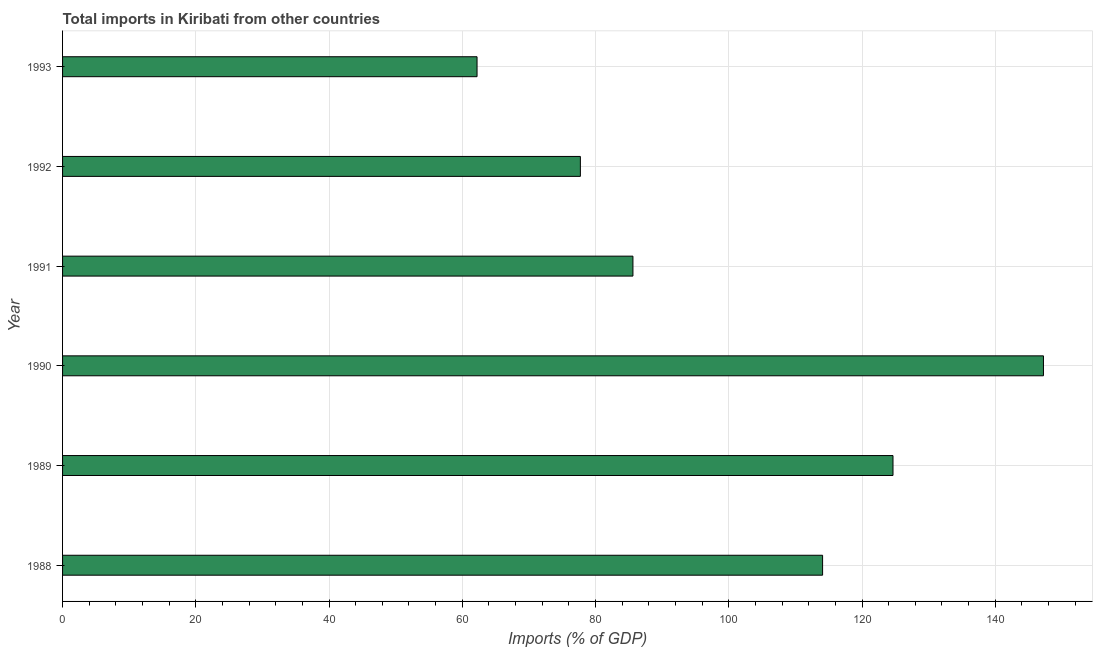Does the graph contain grids?
Your response must be concise. Yes. What is the title of the graph?
Your answer should be very brief. Total imports in Kiribati from other countries. What is the label or title of the X-axis?
Give a very brief answer. Imports (% of GDP). What is the label or title of the Y-axis?
Your answer should be compact. Year. What is the total imports in 1988?
Offer a very short reply. 114.08. Across all years, what is the maximum total imports?
Your response must be concise. 147.24. Across all years, what is the minimum total imports?
Provide a succinct answer. 62.22. In which year was the total imports minimum?
Provide a succinct answer. 1993. What is the sum of the total imports?
Your answer should be compact. 611.54. What is the difference between the total imports in 1989 and 1990?
Your answer should be very brief. -22.58. What is the average total imports per year?
Offer a very short reply. 101.92. What is the median total imports?
Offer a terse response. 99.85. In how many years, is the total imports greater than 64 %?
Give a very brief answer. 5. Do a majority of the years between 1991 and 1989 (inclusive) have total imports greater than 4 %?
Make the answer very short. Yes. What is the ratio of the total imports in 1989 to that in 1993?
Offer a terse response. 2. Is the difference between the total imports in 1992 and 1993 greater than the difference between any two years?
Keep it short and to the point. No. What is the difference between the highest and the second highest total imports?
Your answer should be very brief. 22.58. What is the difference between the highest and the lowest total imports?
Your answer should be very brief. 85.02. In how many years, is the total imports greater than the average total imports taken over all years?
Offer a very short reply. 3. Are the values on the major ticks of X-axis written in scientific E-notation?
Offer a terse response. No. What is the Imports (% of GDP) of 1988?
Provide a short and direct response. 114.08. What is the Imports (% of GDP) in 1989?
Give a very brief answer. 124.65. What is the Imports (% of GDP) in 1990?
Give a very brief answer. 147.24. What is the Imports (% of GDP) of 1991?
Your response must be concise. 85.62. What is the Imports (% of GDP) of 1992?
Provide a short and direct response. 77.73. What is the Imports (% of GDP) of 1993?
Your answer should be very brief. 62.22. What is the difference between the Imports (% of GDP) in 1988 and 1989?
Give a very brief answer. -10.57. What is the difference between the Imports (% of GDP) in 1988 and 1990?
Keep it short and to the point. -33.15. What is the difference between the Imports (% of GDP) in 1988 and 1991?
Ensure brevity in your answer.  28.47. What is the difference between the Imports (% of GDP) in 1988 and 1992?
Provide a succinct answer. 36.36. What is the difference between the Imports (% of GDP) in 1988 and 1993?
Give a very brief answer. 51.87. What is the difference between the Imports (% of GDP) in 1989 and 1990?
Your response must be concise. -22.58. What is the difference between the Imports (% of GDP) in 1989 and 1991?
Make the answer very short. 39.04. What is the difference between the Imports (% of GDP) in 1989 and 1992?
Ensure brevity in your answer.  46.93. What is the difference between the Imports (% of GDP) in 1989 and 1993?
Ensure brevity in your answer.  62.44. What is the difference between the Imports (% of GDP) in 1990 and 1991?
Keep it short and to the point. 61.62. What is the difference between the Imports (% of GDP) in 1990 and 1992?
Your response must be concise. 69.51. What is the difference between the Imports (% of GDP) in 1990 and 1993?
Ensure brevity in your answer.  85.02. What is the difference between the Imports (% of GDP) in 1991 and 1992?
Offer a very short reply. 7.89. What is the difference between the Imports (% of GDP) in 1991 and 1993?
Provide a succinct answer. 23.4. What is the difference between the Imports (% of GDP) in 1992 and 1993?
Ensure brevity in your answer.  15.51. What is the ratio of the Imports (% of GDP) in 1988 to that in 1989?
Ensure brevity in your answer.  0.92. What is the ratio of the Imports (% of GDP) in 1988 to that in 1990?
Offer a very short reply. 0.78. What is the ratio of the Imports (% of GDP) in 1988 to that in 1991?
Provide a succinct answer. 1.33. What is the ratio of the Imports (% of GDP) in 1988 to that in 1992?
Provide a short and direct response. 1.47. What is the ratio of the Imports (% of GDP) in 1988 to that in 1993?
Your answer should be very brief. 1.83. What is the ratio of the Imports (% of GDP) in 1989 to that in 1990?
Your answer should be compact. 0.85. What is the ratio of the Imports (% of GDP) in 1989 to that in 1991?
Ensure brevity in your answer.  1.46. What is the ratio of the Imports (% of GDP) in 1989 to that in 1992?
Your response must be concise. 1.6. What is the ratio of the Imports (% of GDP) in 1989 to that in 1993?
Your answer should be very brief. 2. What is the ratio of the Imports (% of GDP) in 1990 to that in 1991?
Provide a short and direct response. 1.72. What is the ratio of the Imports (% of GDP) in 1990 to that in 1992?
Make the answer very short. 1.89. What is the ratio of the Imports (% of GDP) in 1990 to that in 1993?
Keep it short and to the point. 2.37. What is the ratio of the Imports (% of GDP) in 1991 to that in 1992?
Provide a short and direct response. 1.1. What is the ratio of the Imports (% of GDP) in 1991 to that in 1993?
Give a very brief answer. 1.38. What is the ratio of the Imports (% of GDP) in 1992 to that in 1993?
Offer a terse response. 1.25. 